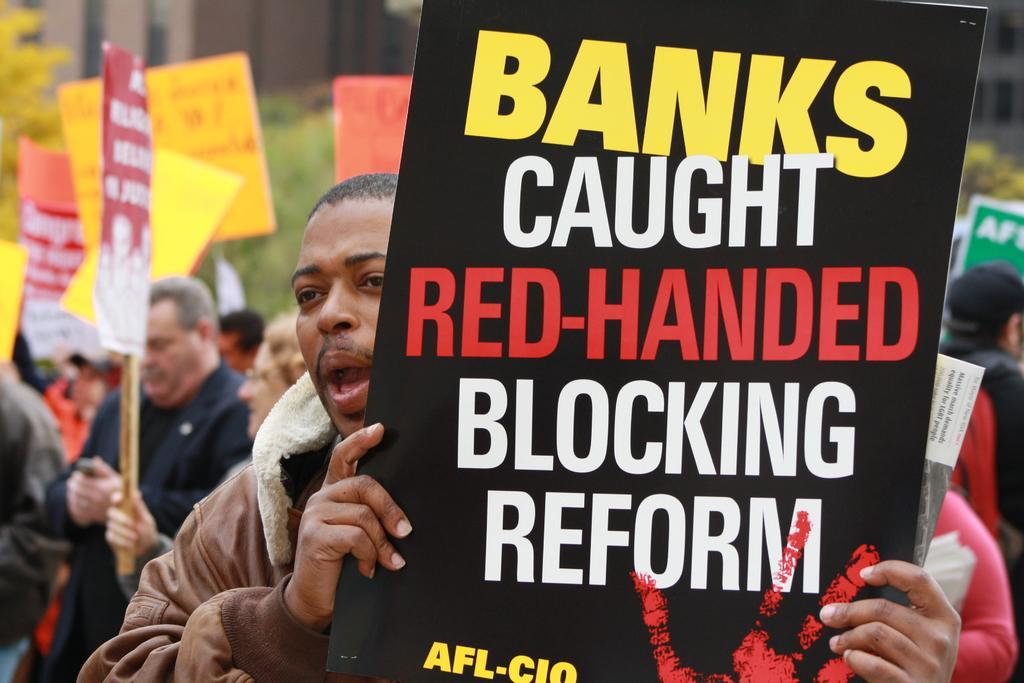Please provide a concise description of this image. In the picture I can see a group of people are standing and holding placards in hands. On these placards I can see something written on them. 